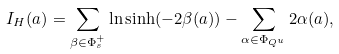Convert formula to latex. <formula><loc_0><loc_0><loc_500><loc_500>I _ { H } ( a ) = \sum _ { \beta \in \Phi _ { s } ^ { + } } \ln \sinh ( - 2 \beta ( a ) ) - \sum _ { \alpha \in \Phi _ { Q ^ { u } } } 2 \alpha ( a ) ,</formula> 